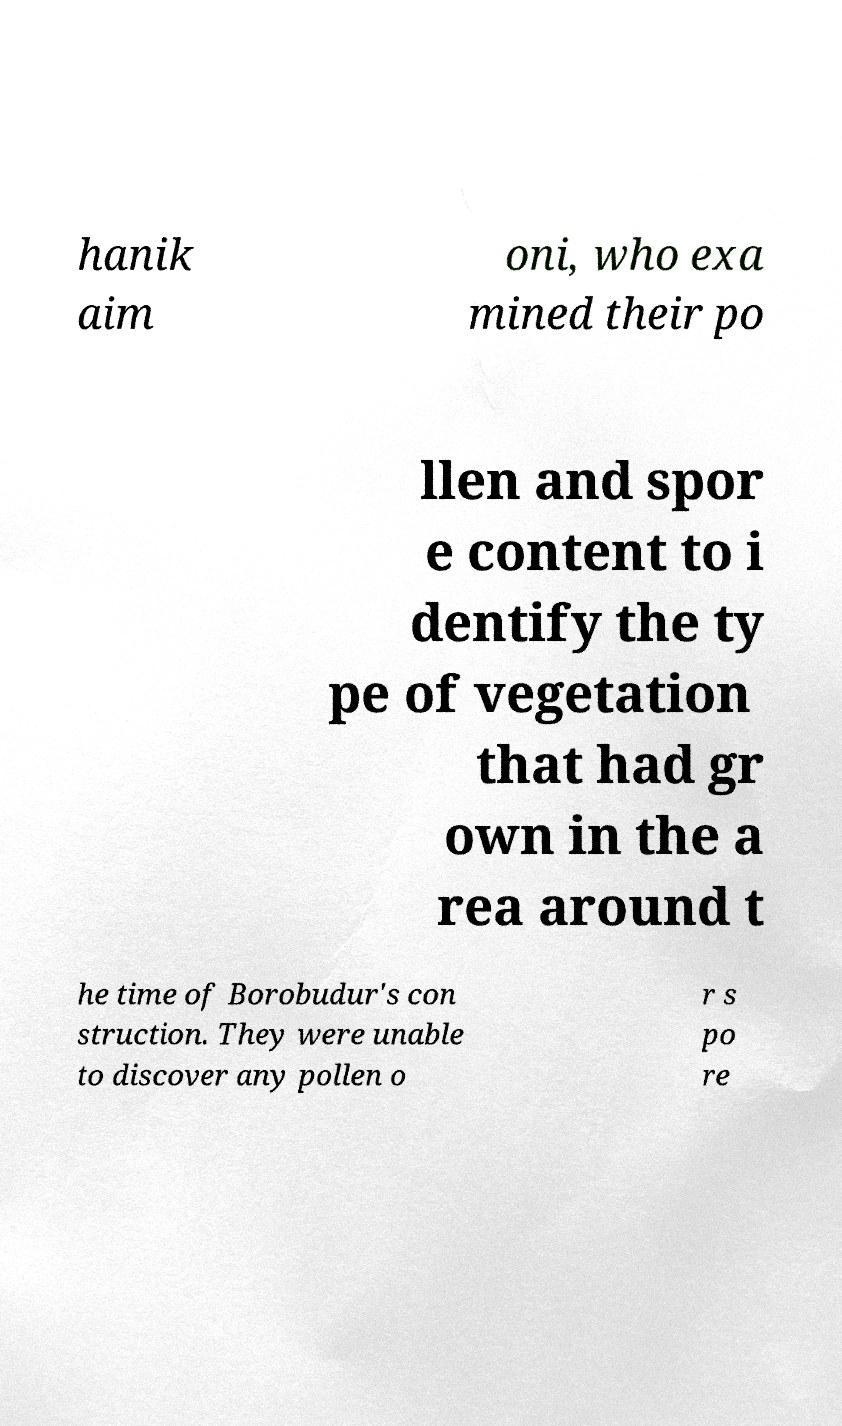There's text embedded in this image that I need extracted. Can you transcribe it verbatim? hanik aim oni, who exa mined their po llen and spor e content to i dentify the ty pe of vegetation that had gr own in the a rea around t he time of Borobudur's con struction. They were unable to discover any pollen o r s po re 